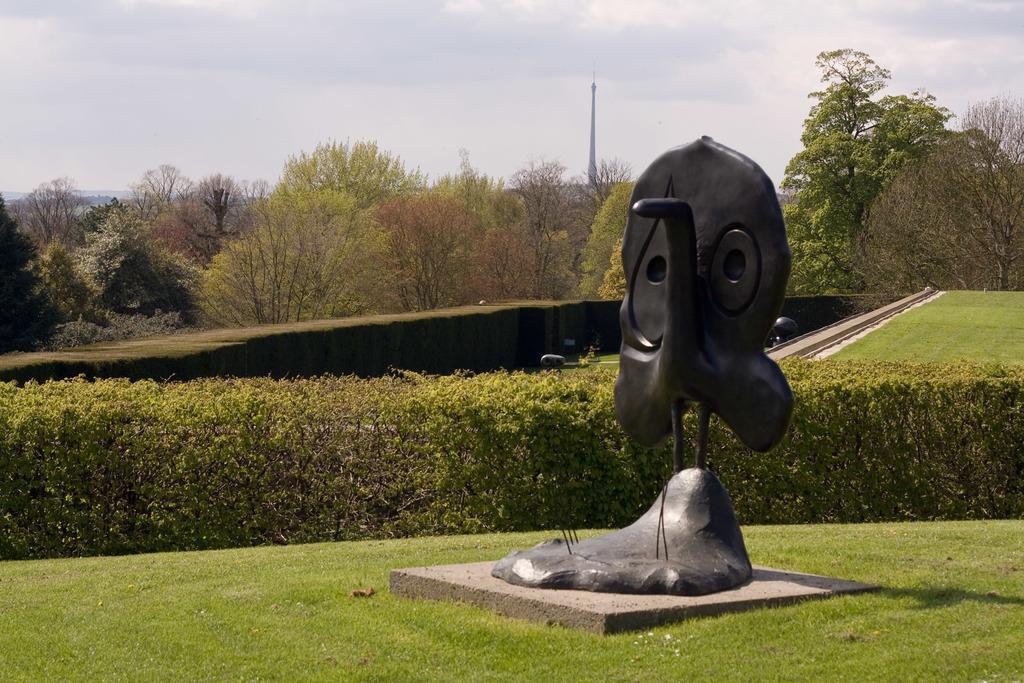Can you describe this image briefly? In this picture we can see a statue on the path and behind the statue where is the hedge, trees, poles and the sky. On the path there are some objects. 